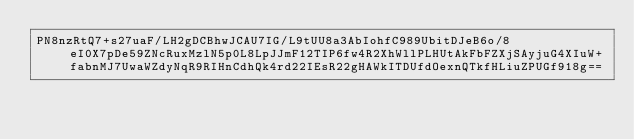<code> <loc_0><loc_0><loc_500><loc_500><_SML_>PN8nzRtQ7+s27uaF/LH2gDCBhwJCAU7IG/L9tUU8a3AbIohfC989UbitDJeB6o/8eI0X7pDe59ZNcRuxMzlN5p0L8LpJJmF12TIP6fw4R2XhWllPLHUtAkFbFZXjSAyjuG4XIuW+fabnMJ7UwaWZdyNqR9RIHnCdhQk4rd22IEsR22gHAWkITDUfdOexnQTkfHLiuZPUGf918g==</code> 